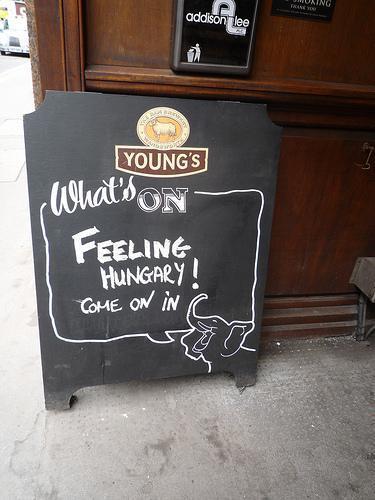How many elephants are on the sign?
Give a very brief answer. 1. 